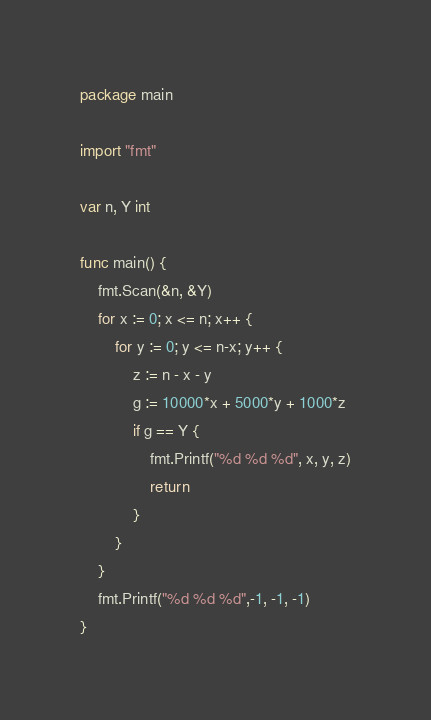<code> <loc_0><loc_0><loc_500><loc_500><_Go_>package main

import "fmt"

var n, Y int

func main() {
	fmt.Scan(&n, &Y)
	for x := 0; x <= n; x++ {
		for y := 0; y <= n-x; y++ {
			z := n - x - y
			g := 10000*x + 5000*y + 1000*z
			if g == Y {
				fmt.Printf("%d %d %d", x, y, z)
				return
			}
		}
	}
	fmt.Printf("%d %d %d",-1, -1, -1)
}
</code> 